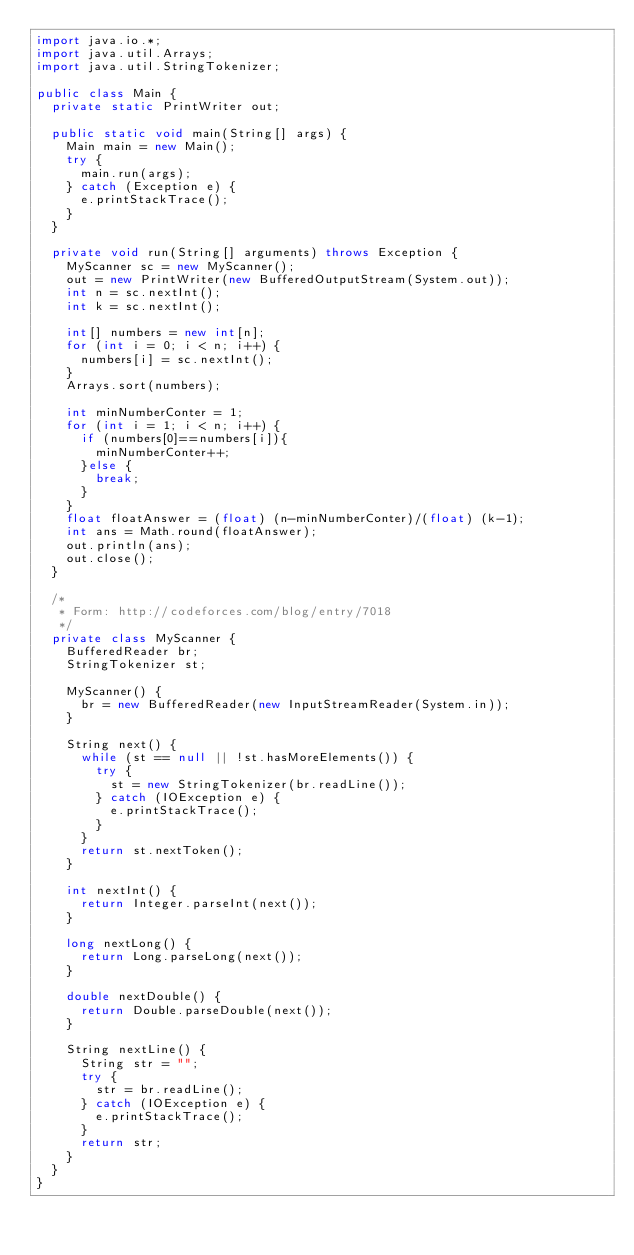Convert code to text. <code><loc_0><loc_0><loc_500><loc_500><_Java_>import java.io.*;
import java.util.Arrays;
import java.util.StringTokenizer;

public class Main {
  private static PrintWriter out;

  public static void main(String[] args) {
    Main main = new Main();
    try {
      main.run(args);
    } catch (Exception e) {
      e.printStackTrace();
    }
  }

  private void run(String[] arguments) throws Exception {
    MyScanner sc = new MyScanner();
    out = new PrintWriter(new BufferedOutputStream(System.out));
    int n = sc.nextInt();
    int k = sc.nextInt();

    int[] numbers = new int[n];
    for (int i = 0; i < n; i++) {
      numbers[i] = sc.nextInt();
    }
    Arrays.sort(numbers);

    int minNumberConter = 1;
    for (int i = 1; i < n; i++) {
      if (numbers[0]==numbers[i]){
        minNumberConter++;
      }else {
        break;
      }
    }
    float floatAnswer = (float) (n-minNumberConter)/(float) (k-1);
    int ans = Math.round(floatAnswer);
    out.println(ans);
    out.close();
  }

  /*          
   * Form: http://codeforces.com/blog/entry/7018
   */
  private class MyScanner {
    BufferedReader br;
    StringTokenizer st;

    MyScanner() {
      br = new BufferedReader(new InputStreamReader(System.in));
    }

    String next() {
      while (st == null || !st.hasMoreElements()) {
        try {
          st = new StringTokenizer(br.readLine());
        } catch (IOException e) {
          e.printStackTrace();
        }
      }
      return st.nextToken();
    }

    int nextInt() {
      return Integer.parseInt(next());
    }

    long nextLong() {
      return Long.parseLong(next());
    }

    double nextDouble() {
      return Double.parseDouble(next());
    }

    String nextLine() {
      String str = "";
      try {
        str = br.readLine();
      } catch (IOException e) {
        e.printStackTrace();
      }
      return str;
    }
  }
}
</code> 